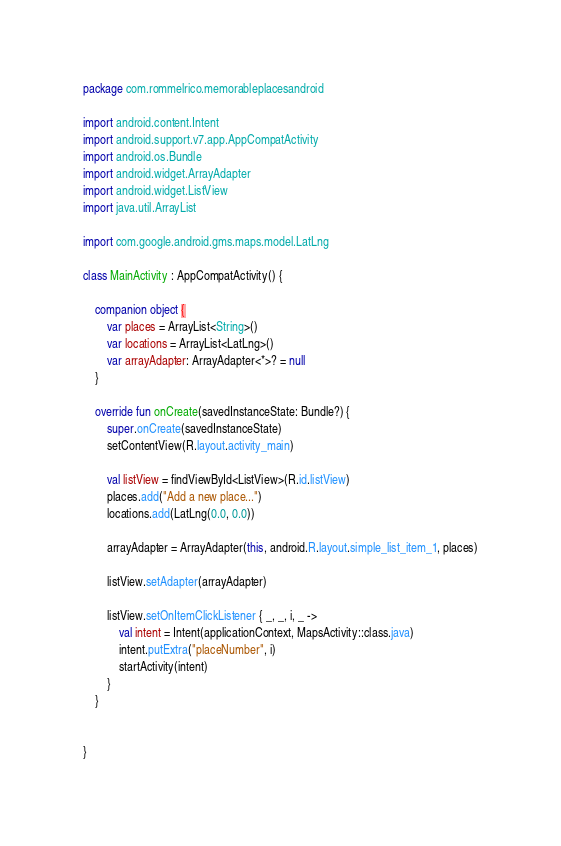Convert code to text. <code><loc_0><loc_0><loc_500><loc_500><_Kotlin_>package com.rommelrico.memorableplacesandroid

import android.content.Intent
import android.support.v7.app.AppCompatActivity
import android.os.Bundle
import android.widget.ArrayAdapter
import android.widget.ListView
import java.util.ArrayList

import com.google.android.gms.maps.model.LatLng

class MainActivity : AppCompatActivity() {

    companion object {
        var places = ArrayList<String>()
        var locations = ArrayList<LatLng>()
        var arrayAdapter: ArrayAdapter<*>? = null
    }

    override fun onCreate(savedInstanceState: Bundle?) {
        super.onCreate(savedInstanceState)
        setContentView(R.layout.activity_main)

        val listView = findViewById<ListView>(R.id.listView)
        places.add("Add a new place...")
        locations.add(LatLng(0.0, 0.0))

        arrayAdapter = ArrayAdapter(this, android.R.layout.simple_list_item_1, places)

        listView.setAdapter(arrayAdapter)

        listView.setOnItemClickListener { _, _, i, _ ->
            val intent = Intent(applicationContext, MapsActivity::class.java)
            intent.putExtra("placeNumber", i)
            startActivity(intent)
        }
    }


}
</code> 